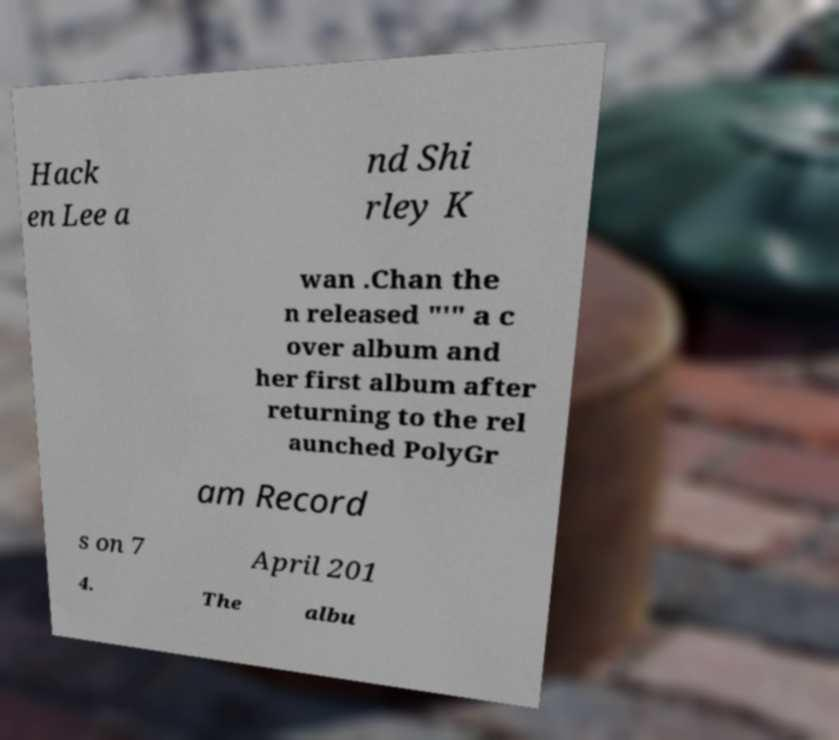Can you read and provide the text displayed in the image?This photo seems to have some interesting text. Can you extract and type it out for me? Hack en Lee a nd Shi rley K wan .Chan the n released "'" a c over album and her first album after returning to the rel aunched PolyGr am Record s on 7 April 201 4. The albu 